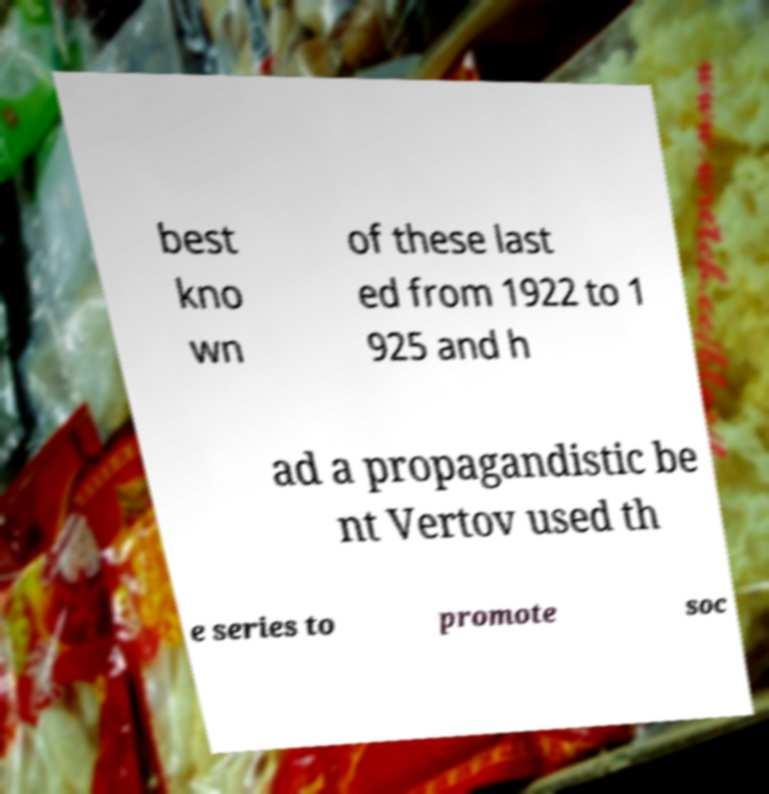Can you accurately transcribe the text from the provided image for me? best kno wn of these last ed from 1922 to 1 925 and h ad a propagandistic be nt Vertov used th e series to promote soc 